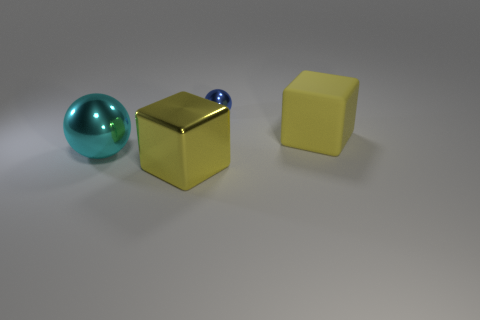Add 4 blue blocks. How many objects exist? 8 Subtract all blue balls. How many balls are left? 1 Subtract 1 blocks. How many blocks are left? 1 Subtract all big cyan metal cylinders. Subtract all big yellow cubes. How many objects are left? 2 Add 1 cyan objects. How many cyan objects are left? 2 Add 2 red metallic cylinders. How many red metallic cylinders exist? 2 Subtract 0 cyan cylinders. How many objects are left? 4 Subtract all brown cubes. Subtract all gray spheres. How many cubes are left? 2 